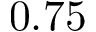Convert formula to latex. <formula><loc_0><loc_0><loc_500><loc_500>0 . 7 5</formula> 